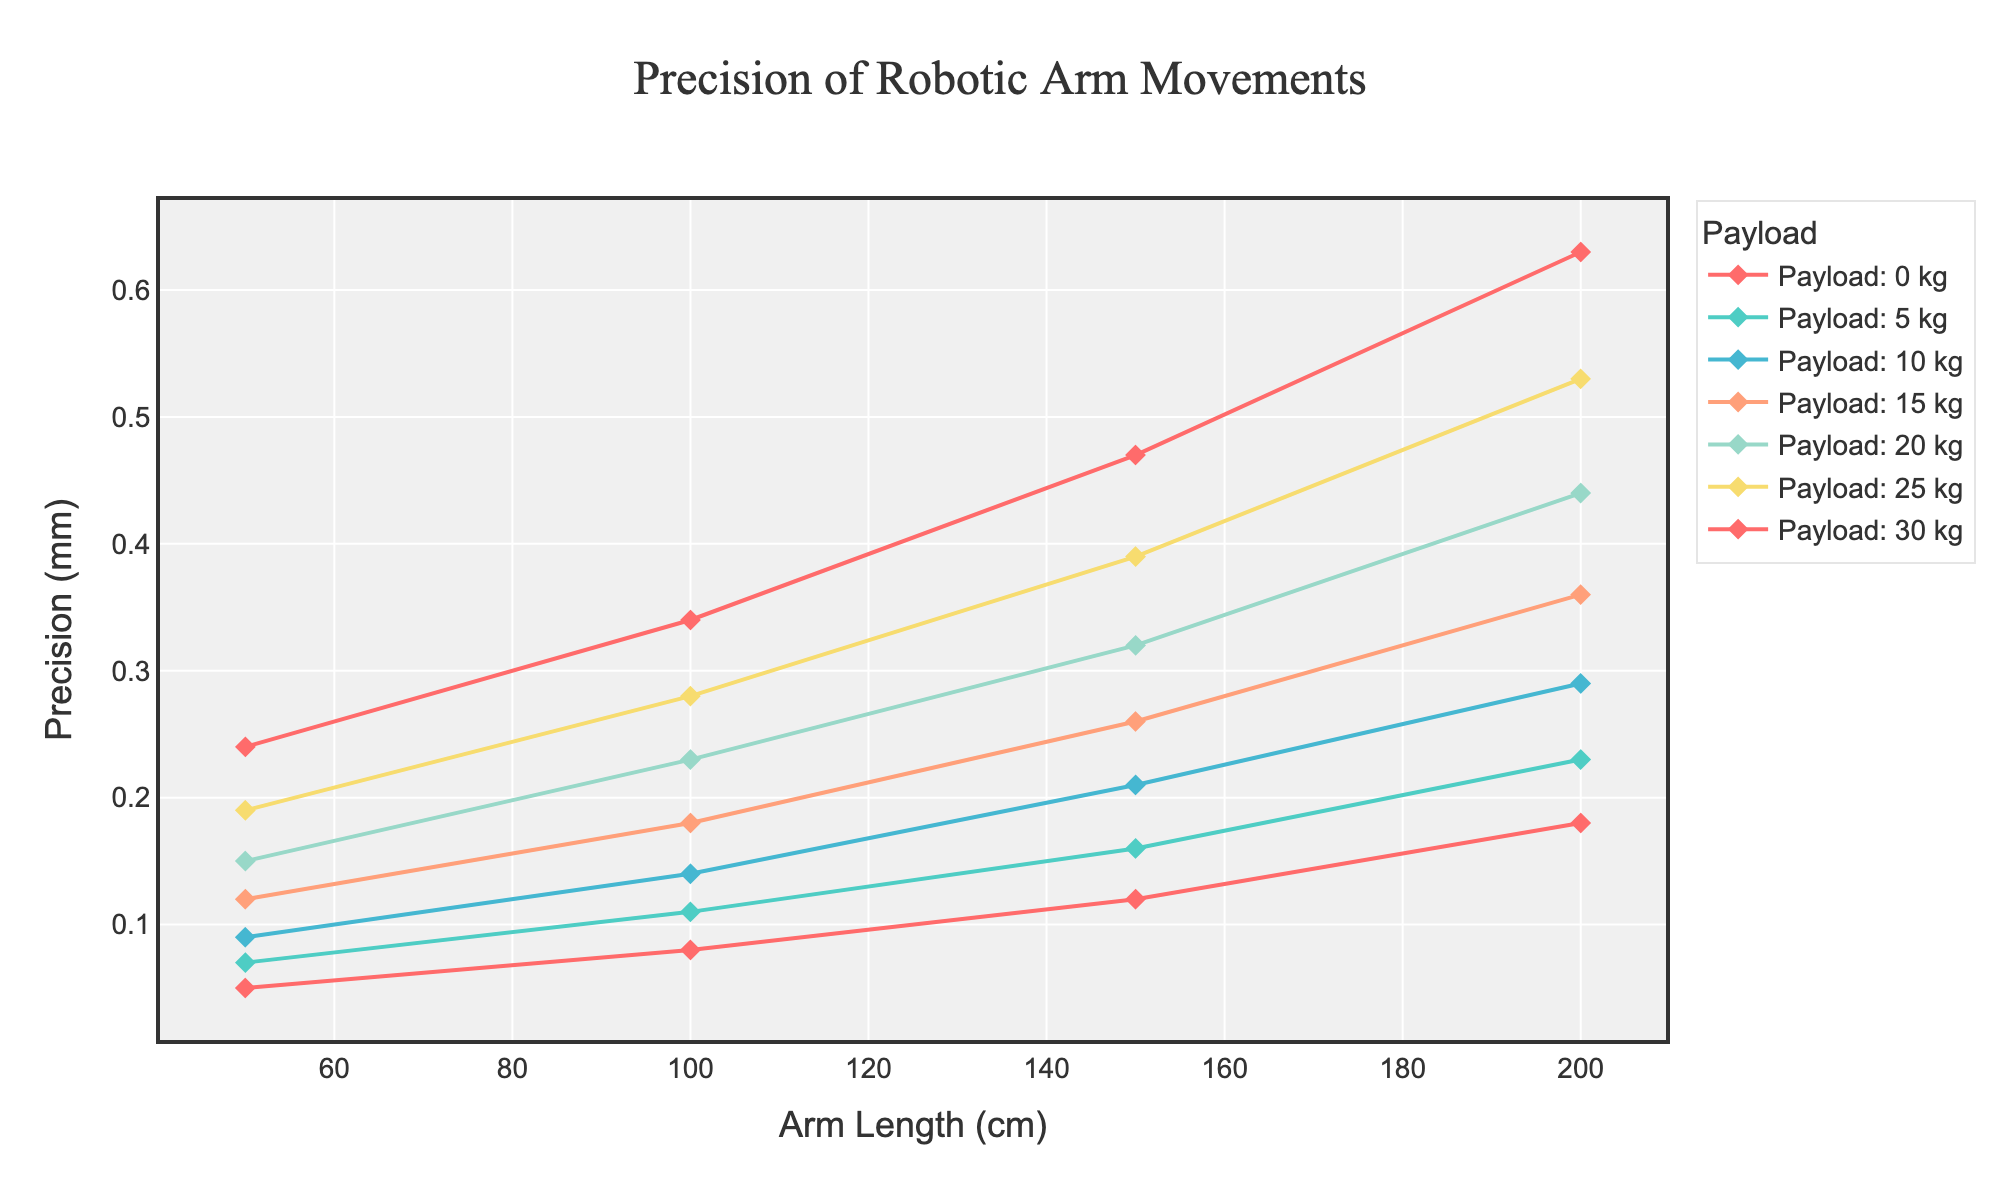What is the precision of the robotic arm at 150 cm arm length with a 10 kg payload? Find the line representing the 10 kg payload and trace it to the 150 cm arm length value. The corresponding precision value is 0.21 mm.
Answer: 0.21 mm How does the precision change from 50 cm to 200 cm for a 0 kg payload? Look at the line for the 0 kg payload from 50 cm to 200 cm. The precision increases from 0.05 mm to 0.18 mm.
Answer: Increases by 0.13 mm Which payload shows the highest precision at 200 cm arm length? Compare the precision values of all payloads at 200 cm arm length. The 30 kg payload has the highest precision value of 0.63 mm.
Answer: 30 kg What is the difference in precision between 100 cm and 150 cm arm length for a 20 kg payload? Find the values for the 20 kg payload at 100 cm (0.23 mm) and 150 cm (0.32 mm). Subtract 0.23 mm from 0.32 mm to get the difference.
Answer: 0.09 mm Which payload exhibits the least increase in precision from 50 cm to 100 cm? Compare the precision increase for each payload from 50 cm to 100 cm. The 0 kg payload shows an increase from 0.05 mm to 0.08 mm, the smallest increase.
Answer: 0 kg At which arm length does the precision remain below 0.2 mm for all payloads? Look at the precision values across all payloads and arm lengths. At 50 cm, all payloads have precision values below 0.2 mm.
Answer: 50 cm How does the precision for the 5 kg payload compare at 50 cm and 200 cm arm lengths? Compare the values of 5 kg payload at 50 cm (0.07 mm) and 200 cm (0.23 mm). The precision increases by 0.16 mm.
Answer: Increases by 0.16 mm Which payload and arm length combination results in a precision of approximately 0.11 mm? Check the precision values close to 0.11 mm, which occurs for the 5 kg payload at 100 cm arm length.
Answer: 5 kg, 100 cm What is the average precision for all arm lengths when carrying a 25 kg payload? Sum the precision values for a 25 kg payload at all arm lengths (0.19 mm, 0.28 mm, 0.39 mm, 0.53 mm) and divide by 4.
Answer: 0.3475 mm What is the median precision value for 30 kg payload across all arm lengths? List the precision values for 30 kg payload (0.24 mm, 0.34 mm, 0.47 mm, 0.63 mm) and find the median value, which is the average of 0.34 mm and 0.47 mm.
Answer: 0.405 mm 